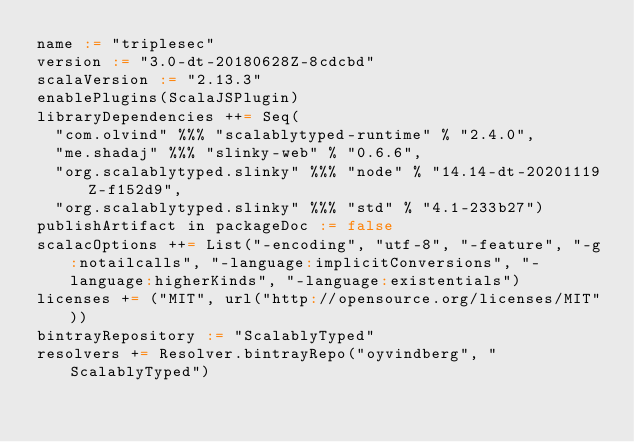Convert code to text. <code><loc_0><loc_0><loc_500><loc_500><_Scala_>name := "triplesec"
version := "3.0-dt-20180628Z-8cdcbd"
scalaVersion := "2.13.3"
enablePlugins(ScalaJSPlugin)
libraryDependencies ++= Seq(
  "com.olvind" %%% "scalablytyped-runtime" % "2.4.0",
  "me.shadaj" %%% "slinky-web" % "0.6.6",
  "org.scalablytyped.slinky" %%% "node" % "14.14-dt-20201119Z-f152d9",
  "org.scalablytyped.slinky" %%% "std" % "4.1-233b27")
publishArtifact in packageDoc := false
scalacOptions ++= List("-encoding", "utf-8", "-feature", "-g:notailcalls", "-language:implicitConversions", "-language:higherKinds", "-language:existentials")
licenses += ("MIT", url("http://opensource.org/licenses/MIT"))
bintrayRepository := "ScalablyTyped"
resolvers += Resolver.bintrayRepo("oyvindberg", "ScalablyTyped")
</code> 